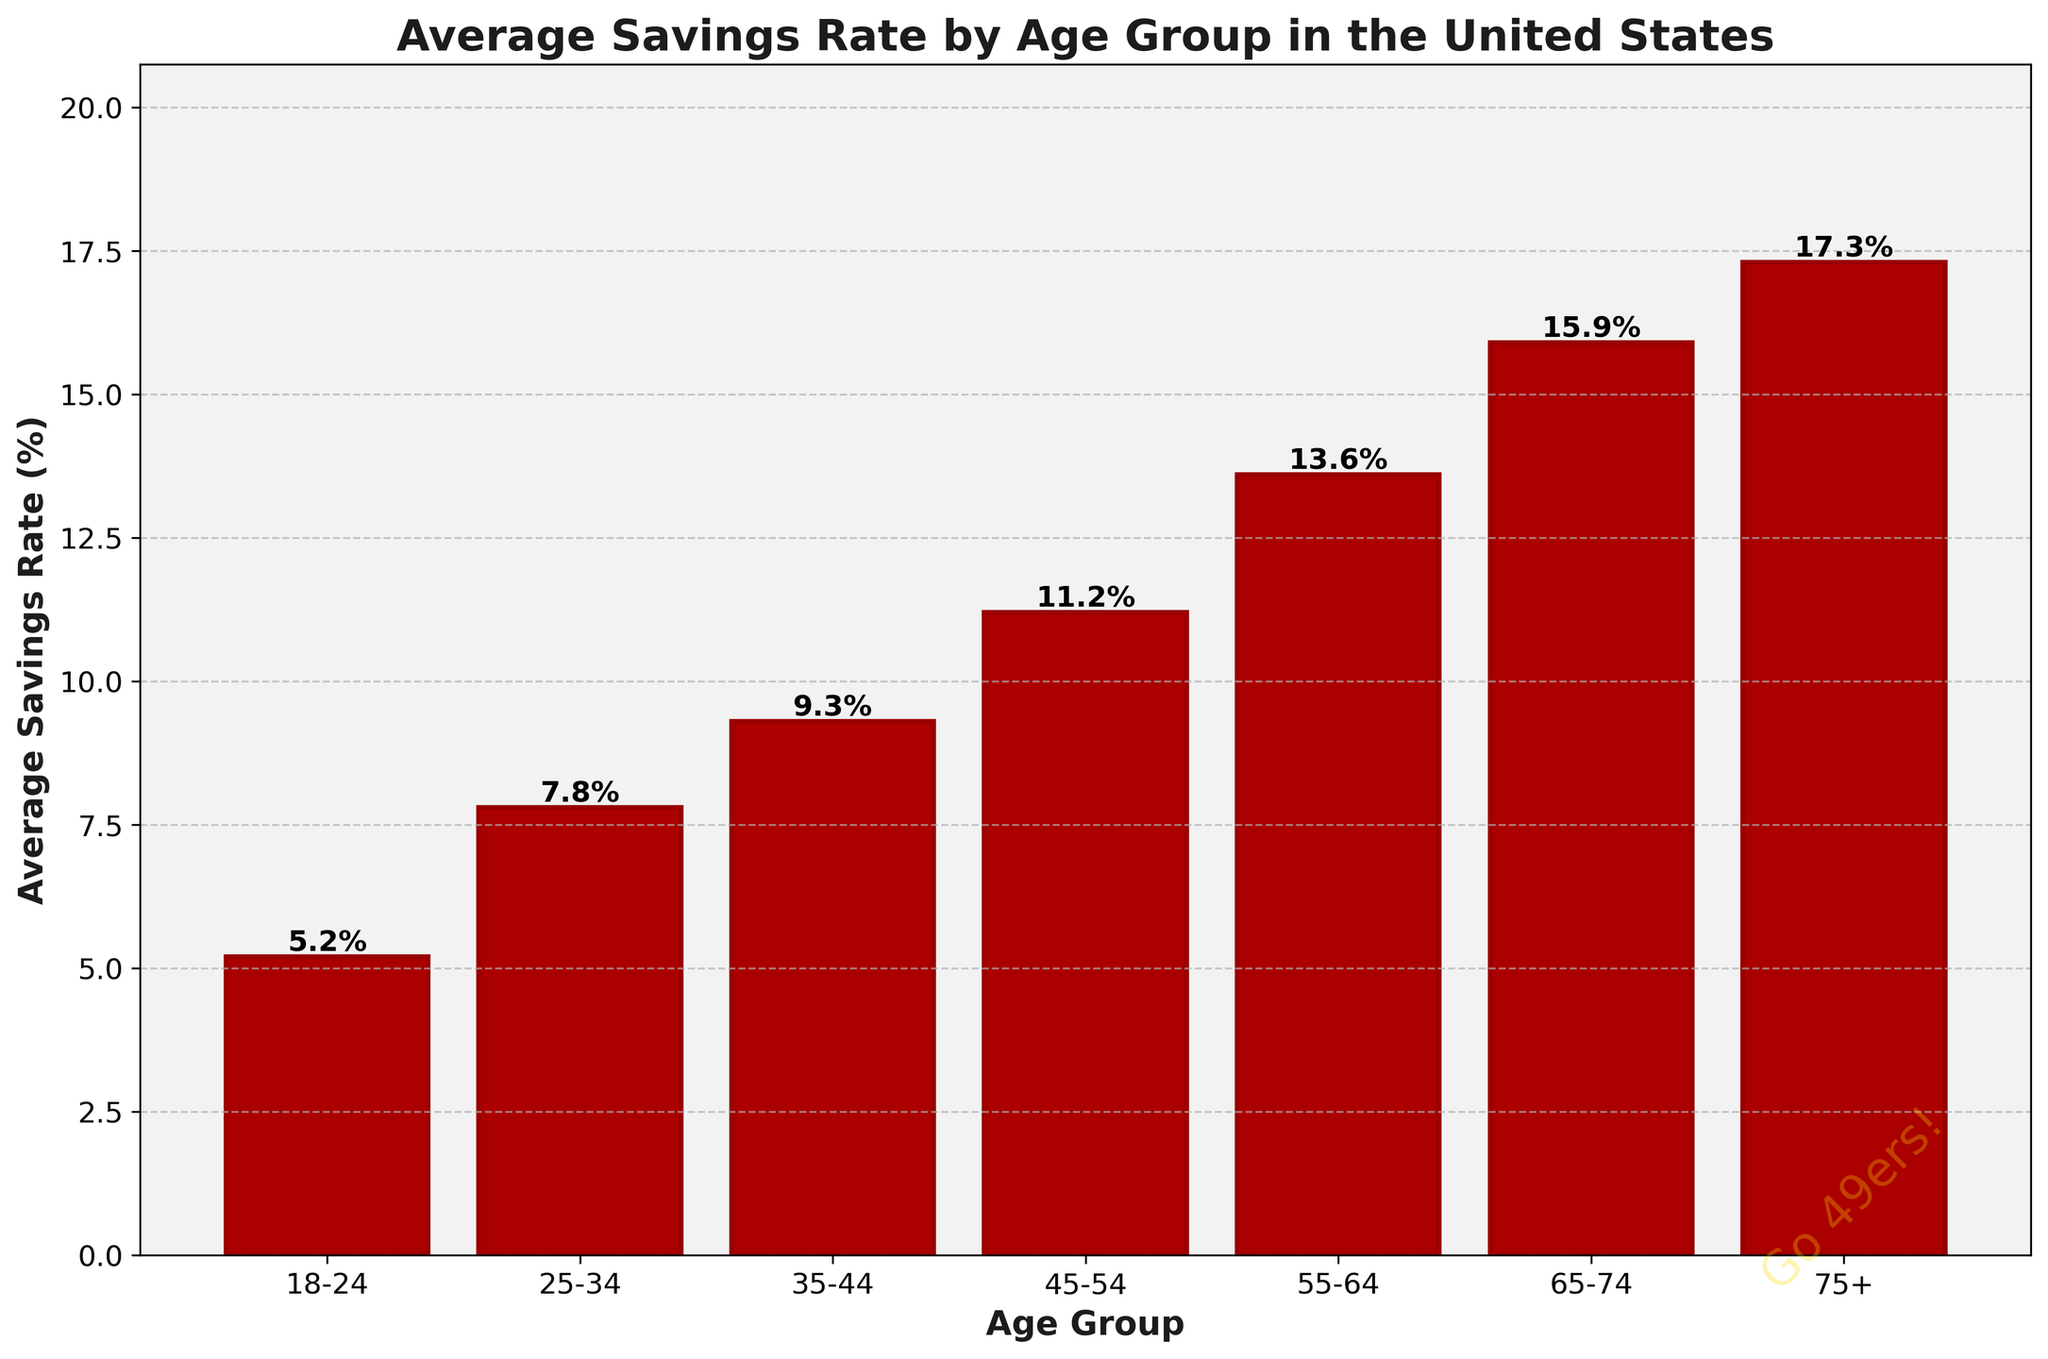Which age group has the highest average savings rate? The height of the bar indicating the savings rate for the "75+" age group is the tallest among all the age groups, representing the highest value.
Answer: 75+ Which age group has the lowest average savings rate? The bar for the "18-24" age group is the shortest, indicating the lowest average savings rate.
Answer: 18-24 How does the average savings rate for the 35-44 age group compare to the 25-34 age group? The bar for the 35-44 age group is taller than the one for the 25-34 age group, indicating a higher savings rate. Specifically, 9.3% vs. 7.8%.
Answer: Higher What is the difference in average savings rate between the 55-64 and 45-54 age groups? The average savings rate for the 55-64 group is 13.6%, and for the 45-54 group, it is 11.2%. Subtract 11.2 from 13.6 to get the difference.
Answer: 2.4% What is the overall trend in average savings rates as age increases? The bars progressively get taller as the age groups increase, indicating that the average savings rate generally increases with age.
Answer: Increases How much higher is the average savings rate for the 75+ age group compared to the 18-24 age group? The average savings rate for the 75+ group is 17.3%, and for the 18-24 group, it is 5.2%. Subtract 5.2 from 17.3 to find the difference.
Answer: 12.1% What is the combined average savings rate for the 25-34 and 35-44 age groups? Add the average savings rates of 7.8% for the 25-34 age group and 9.3% for the 35-44 age group to find the total combined rate.
Answer: 17.1% Is the average savings rate for the 65-74 age group closer to the 55-64 group or the 75+ group? The average savings rate for the 65-74 group is 15.9%. Compare the differences: (15.9 - 13.6) = 2.3 and (17.3 - 15.9) = 1.4. The 2.3 is larger, meaning it's closer to the 75+ group.
Answer: 75+ What's the average increase in savings rate per age group from 18-24 to 55-64? The savings rates are 5.2%, 7.8%, 9.3%, 11.2%, and 13.6%. Calculate the differences: (7.8 - 5.2), (9.3 - 7.8), (11.2 - 9.3), and (13.6 - 11.2). Then average these differences: 2.6, 1.5, 1.9, 2.4. The average increase per group is (2.6 + 1.5 + 1.9 + 2.4)/4.
Answer: 2.1% Which age group's savings rate is represented by a bar that is about twice the height of the 18-24 age group's bar? The 25-34 age group's savings rate is 7.8%, which is about twice as large as the 18-24 age group's rate of 5.2%.
Answer: 25-34 